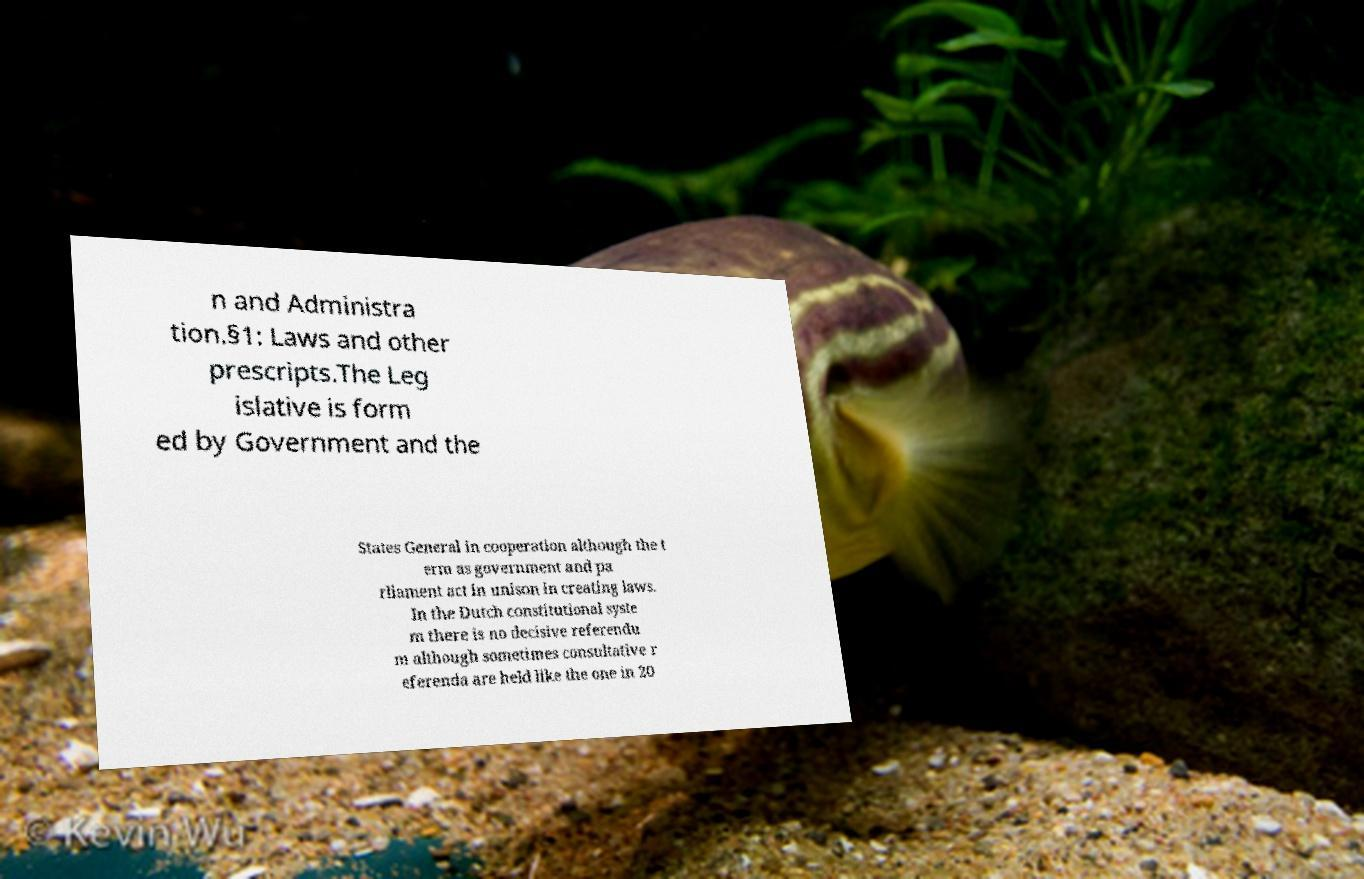There's text embedded in this image that I need extracted. Can you transcribe it verbatim? n and Administra tion.§1: Laws and other prescripts.The Leg islative is form ed by Government and the States General in cooperation although the t erm as government and pa rliament act in unison in creating laws. In the Dutch constitutional syste m there is no decisive referendu m although sometimes consultative r eferenda are held like the one in 20 